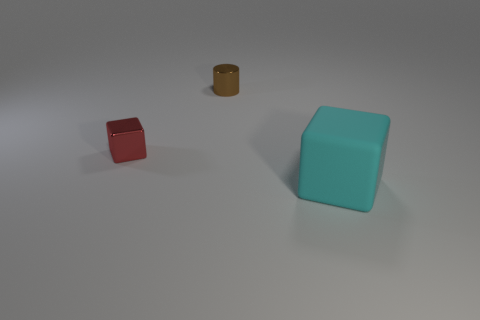Add 2 small green shiny cylinders. How many objects exist? 5 Subtract all blocks. How many objects are left? 1 Add 3 tiny cyan matte spheres. How many tiny cyan matte spheres exist? 3 Subtract 0 blue balls. How many objects are left? 3 Subtract all tiny red metal cubes. Subtract all small red objects. How many objects are left? 1 Add 3 small brown shiny objects. How many small brown shiny objects are left? 4 